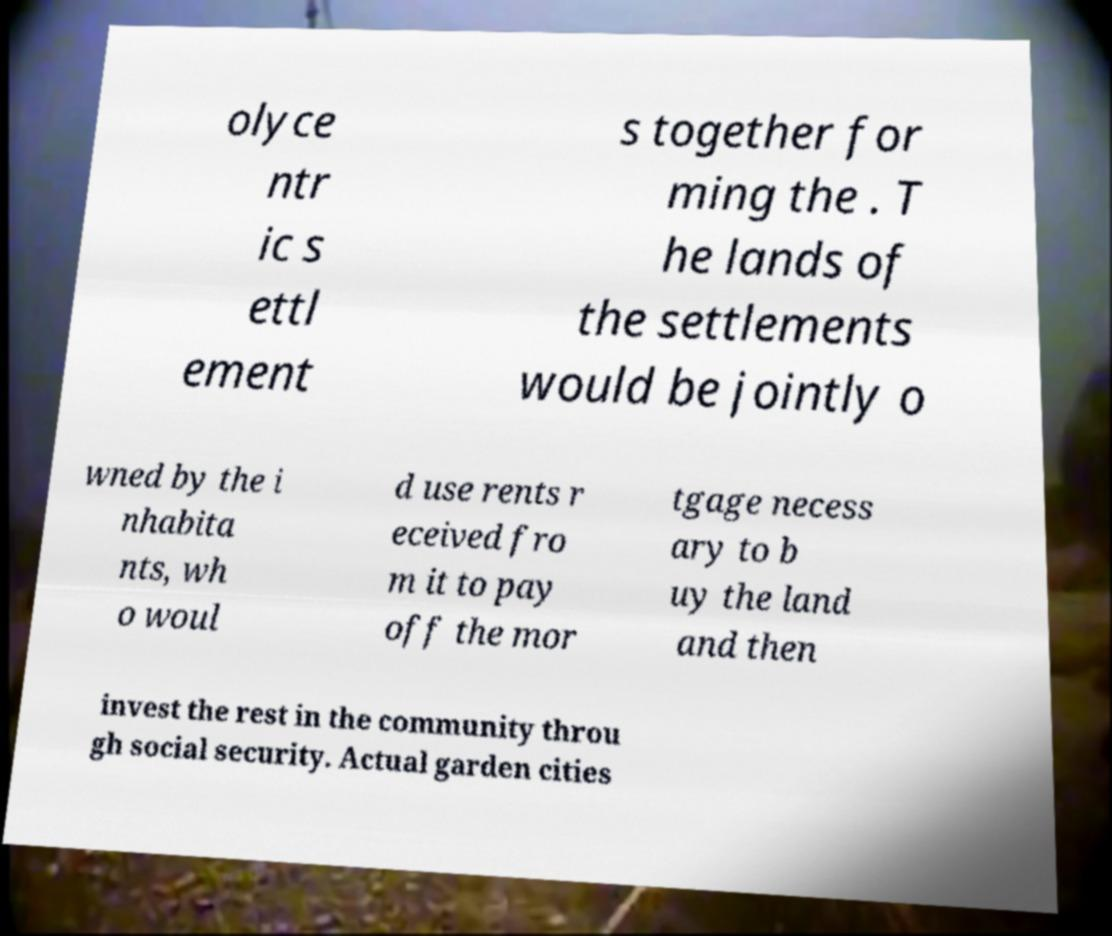Please identify and transcribe the text found in this image. olyce ntr ic s ettl ement s together for ming the . T he lands of the settlements would be jointly o wned by the i nhabita nts, wh o woul d use rents r eceived fro m it to pay off the mor tgage necess ary to b uy the land and then invest the rest in the community throu gh social security. Actual garden cities 